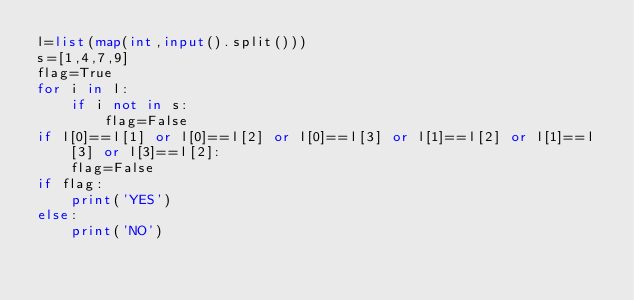<code> <loc_0><loc_0><loc_500><loc_500><_Python_>l=list(map(int,input().split()))
s=[1,4,7,9]
flag=True
for i in l:
    if i not in s:
        flag=False
if l[0]==l[1] or l[0]==l[2] or l[0]==l[3] or l[1]==l[2] or l[1]==l[3] or l[3]==l[2]:
    flag=False
if flag:
    print('YES')
else:
    print('NO')</code> 